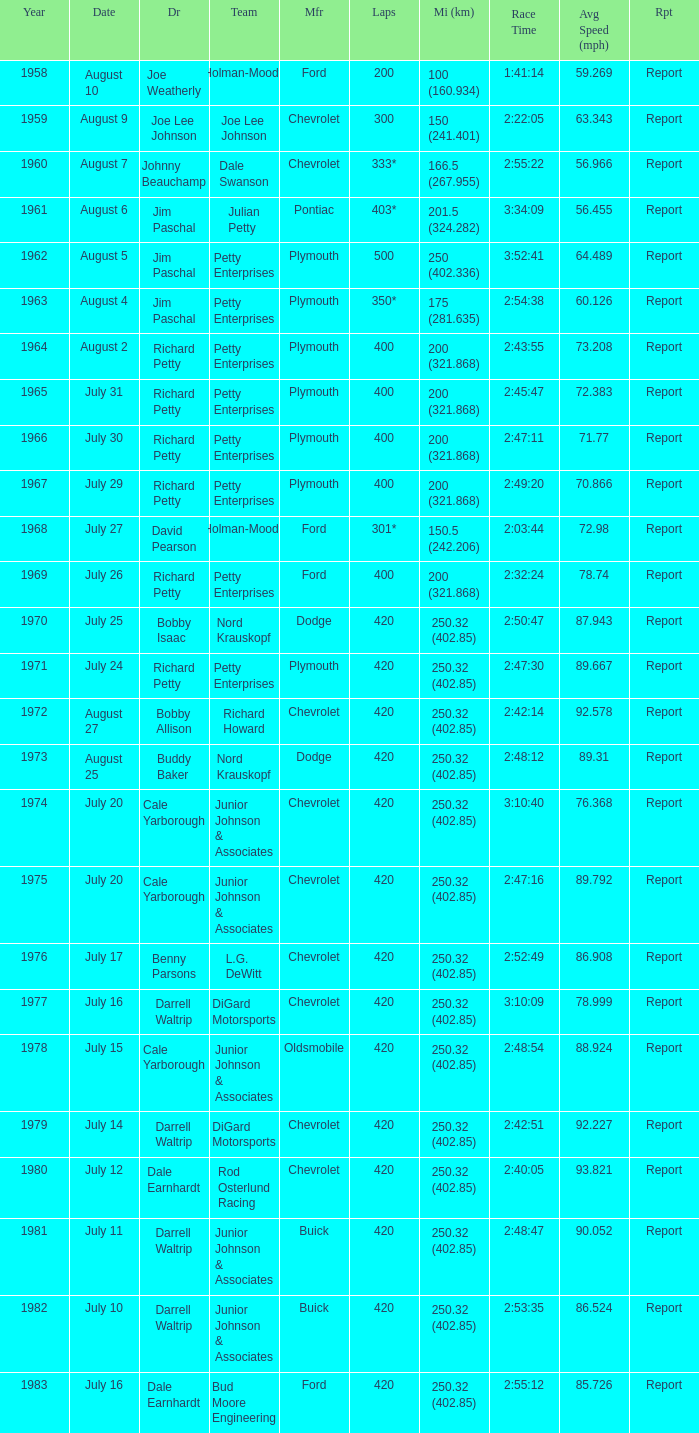Which year included a race of 301* laps? 1968.0. 